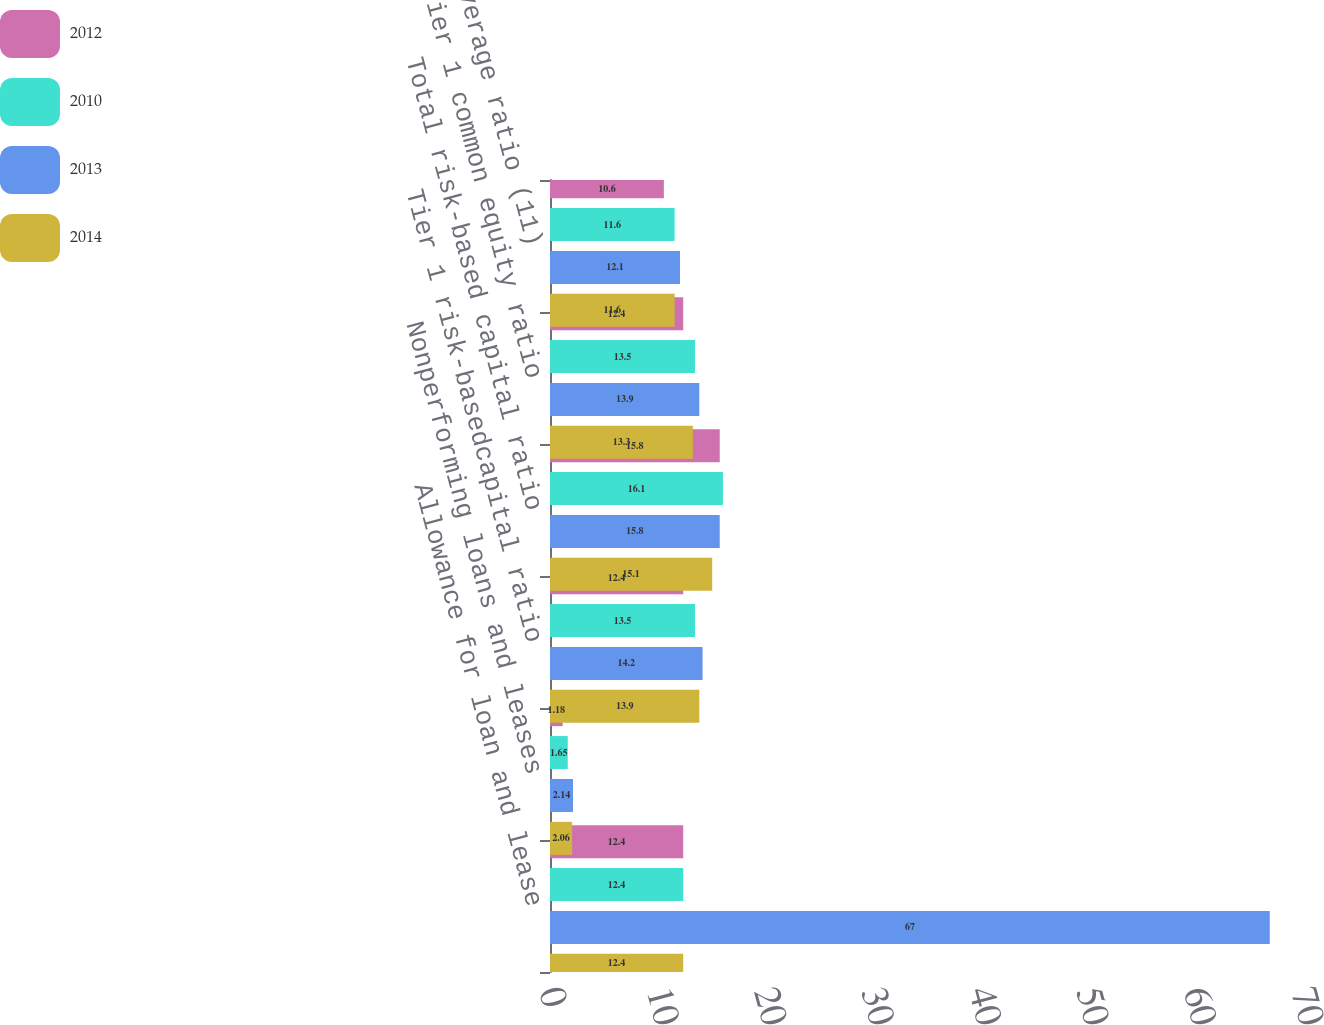Convert chart to OTSL. <chart><loc_0><loc_0><loc_500><loc_500><stacked_bar_chart><ecel><fcel>Allowance for loan and lease<fcel>Nonperforming loans and leases<fcel>Tier 1 risk-basedcapital ratio<fcel>Total risk-based capital ratio<fcel>Tier 1 common equity ratio<fcel>Tier 1 leverage ratio (11)<nl><fcel>2012<fcel>12.4<fcel>1.18<fcel>12.4<fcel>15.8<fcel>12.4<fcel>10.6<nl><fcel>2010<fcel>12.4<fcel>1.65<fcel>13.5<fcel>16.1<fcel>13.5<fcel>11.6<nl><fcel>2013<fcel>67<fcel>2.14<fcel>14.2<fcel>15.8<fcel>13.9<fcel>12.1<nl><fcel>2014<fcel>12.4<fcel>2.06<fcel>13.9<fcel>15.1<fcel>13.3<fcel>11.6<nl></chart> 